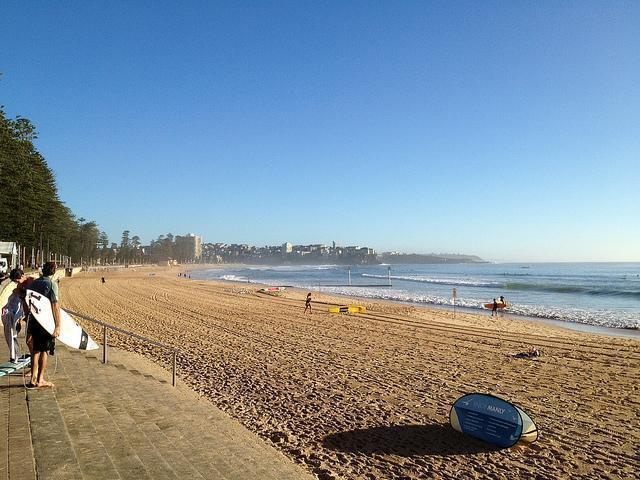How many brown horses are jumping in this photo?
Give a very brief answer. 0. 